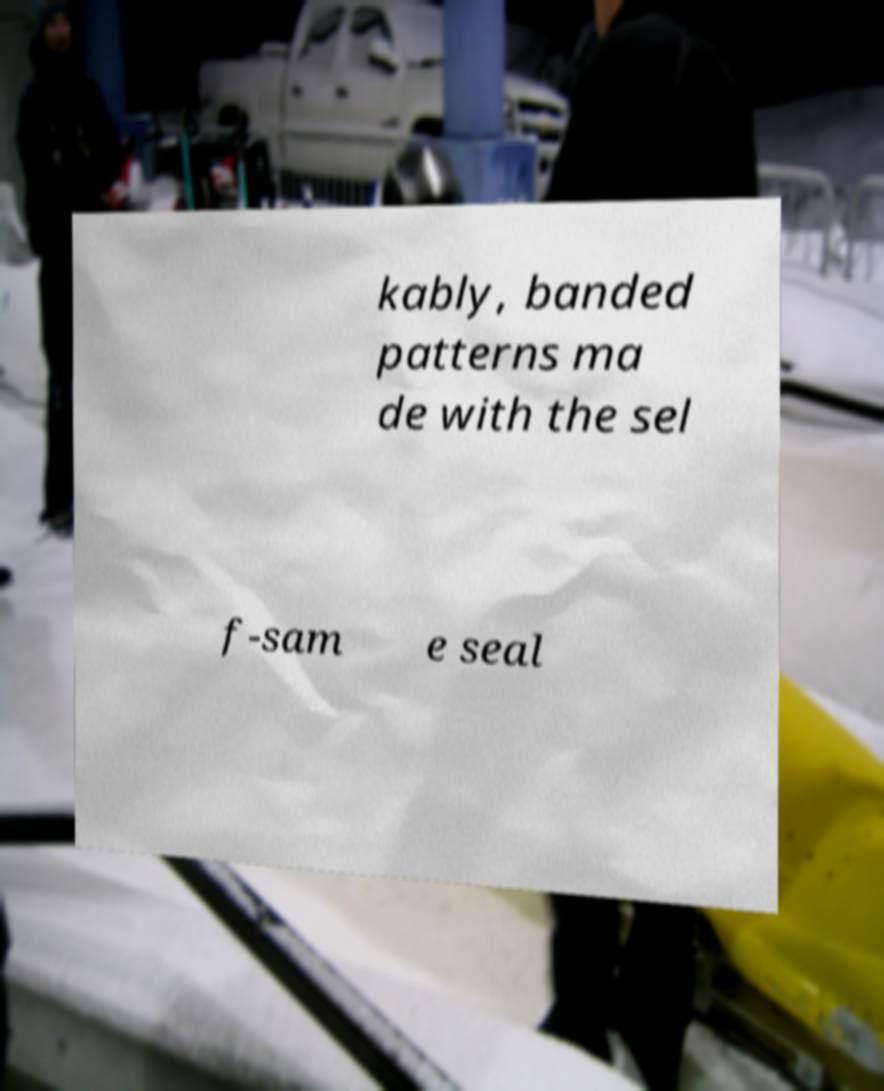Please read and relay the text visible in this image. What does it say? kably, banded patterns ma de with the sel f-sam e seal 